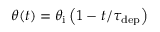Convert formula to latex. <formula><loc_0><loc_0><loc_500><loc_500>\theta ( t ) = \theta _ { i } \left ( 1 - { t } / { \tau _ { d e p } } \right )</formula> 